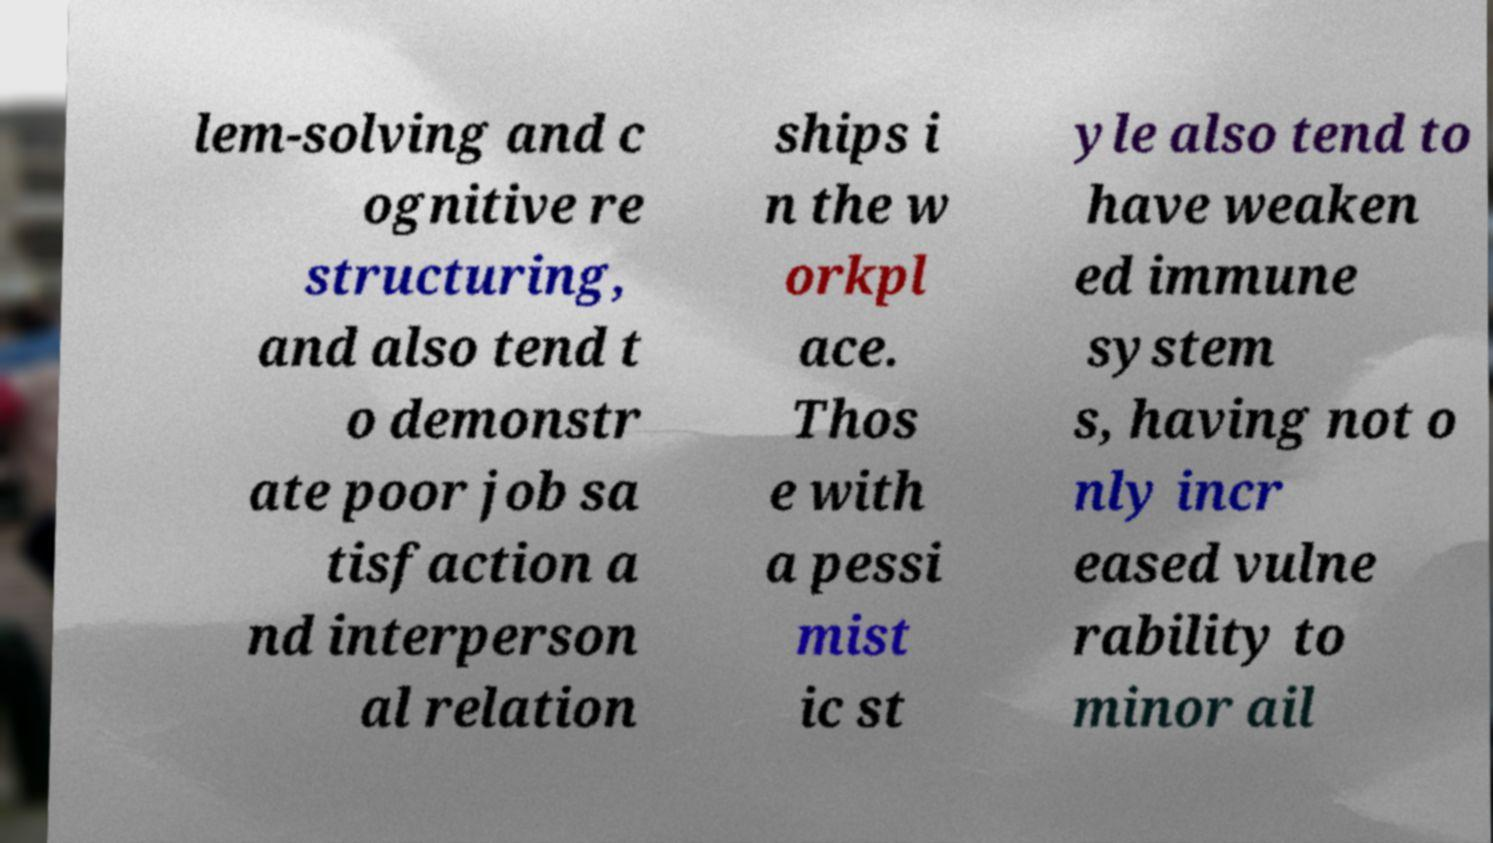Please identify and transcribe the text found in this image. lem-solving and c ognitive re structuring, and also tend t o demonstr ate poor job sa tisfaction a nd interperson al relation ships i n the w orkpl ace. Thos e with a pessi mist ic st yle also tend to have weaken ed immune system s, having not o nly incr eased vulne rability to minor ail 